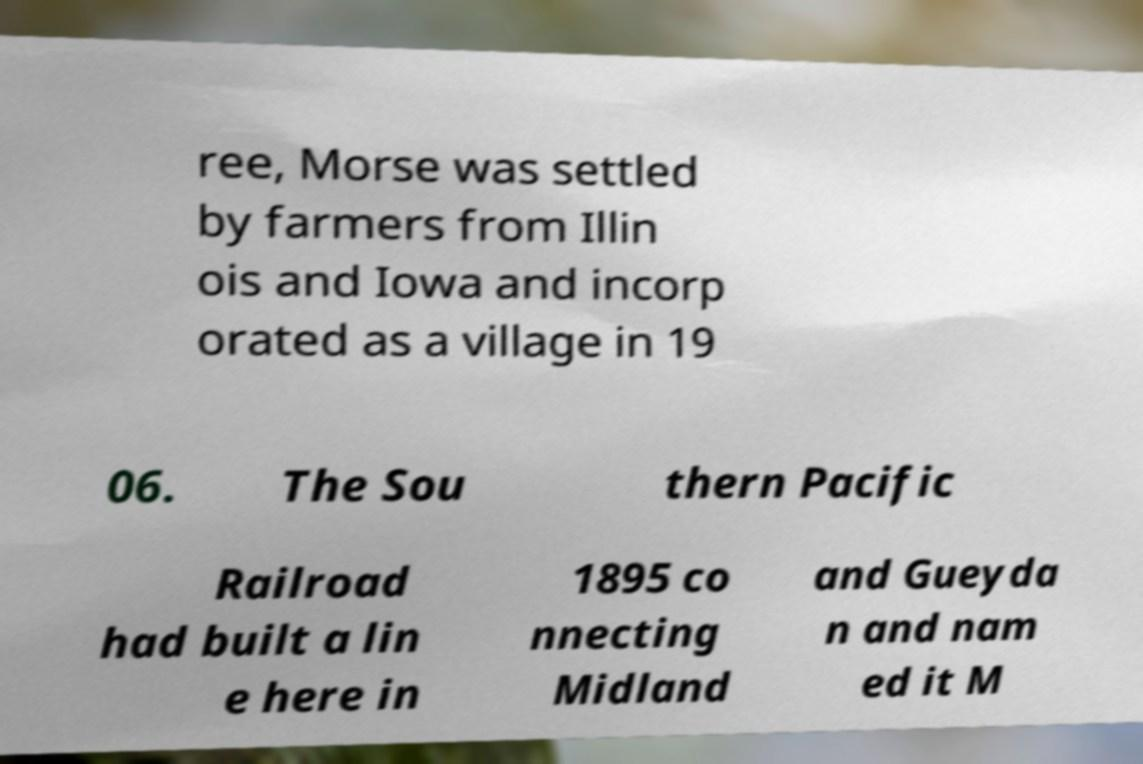There's text embedded in this image that I need extracted. Can you transcribe it verbatim? ree, Morse was settled by farmers from Illin ois and Iowa and incorp orated as a village in 19 06. The Sou thern Pacific Railroad had built a lin e here in 1895 co nnecting Midland and Gueyda n and nam ed it M 